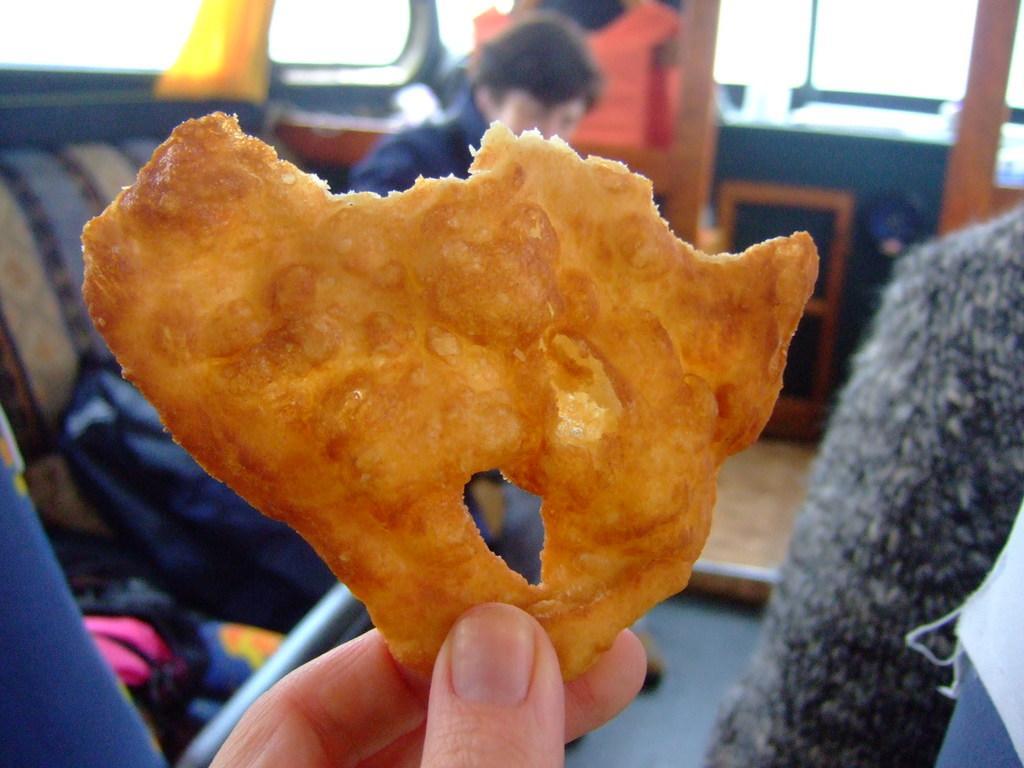Can you describe this image briefly? In the picture there is a person holding the food item with the fingers, beside we can see a person, the image is slightly blurred. 